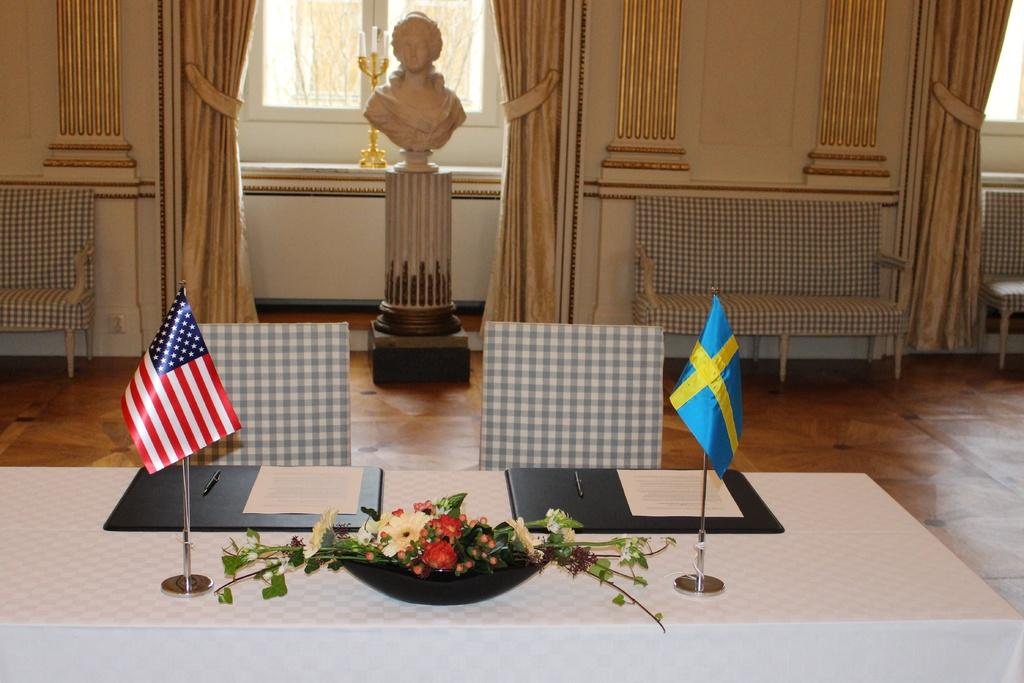What type of artwork can be seen in the room? There is a sculpture in the room. What type of furniture is in the room? There is a sofa in the room. What is on the table in the room? There is a table with a flower vase in the room. What type of window treatment is in the room? There are curtains in the room. What type of fruit is being requested by the sculpture in the image? There is no fruit or request present in the image; it features a sculpture, a sofa, a table with a flower vase, and curtains. What is the sculpture's reaction to the shocking news in the image? There is no shocking news or reaction present in the image; it only features a sculpture, a sofa, a table with a flower vase, and curtains. 